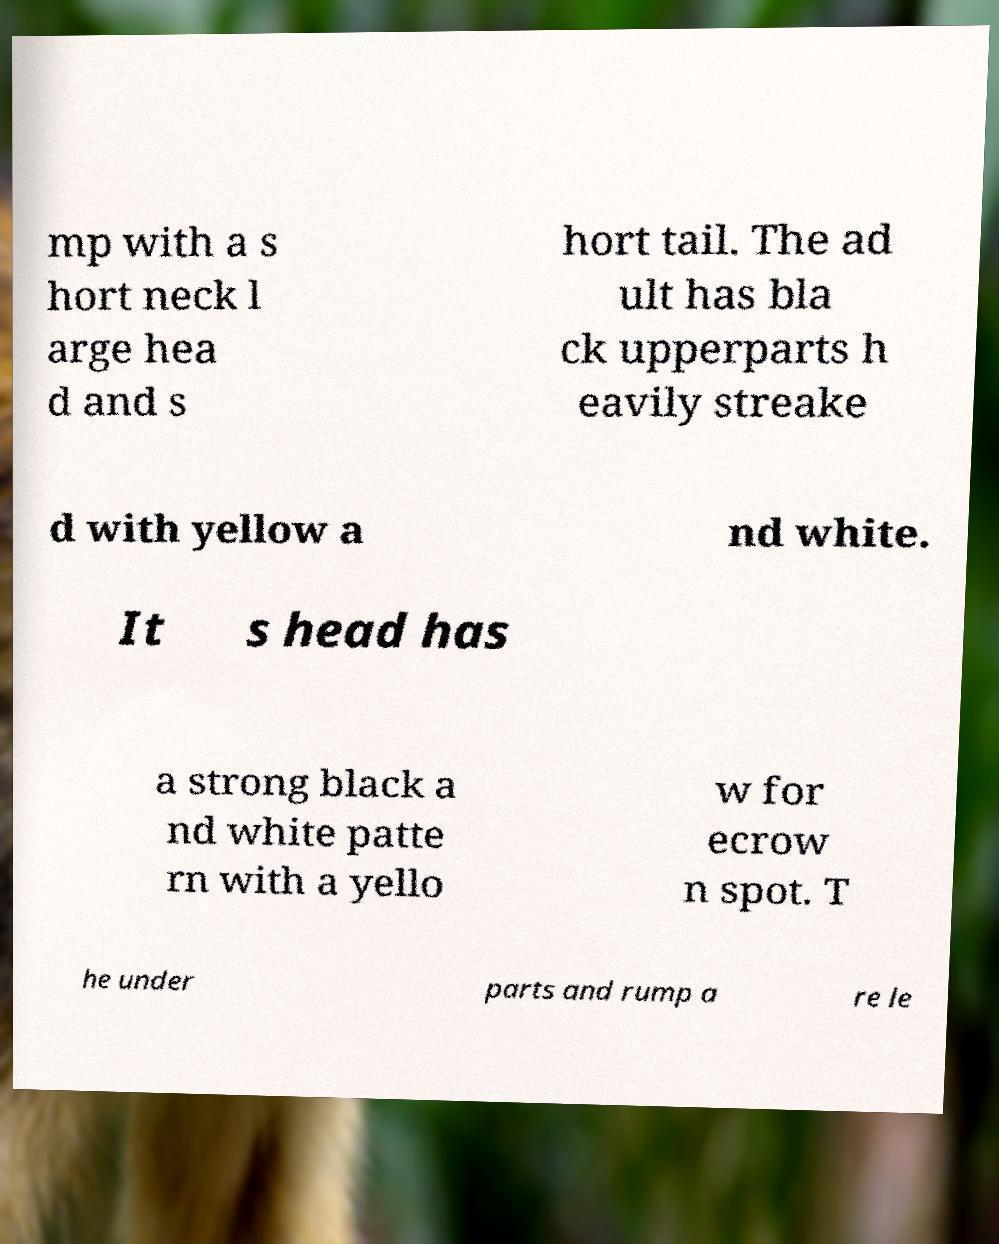Please read and relay the text visible in this image. What does it say? mp with a s hort neck l arge hea d and s hort tail. The ad ult has bla ck upperparts h eavily streake d with yellow a nd white. It s head has a strong black a nd white patte rn with a yello w for ecrow n spot. T he under parts and rump a re le 